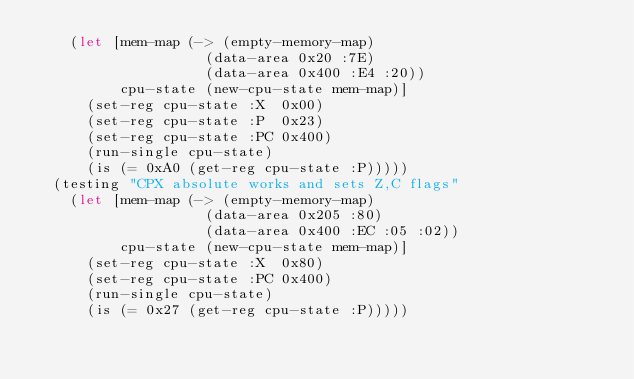<code> <loc_0><loc_0><loc_500><loc_500><_Clojure_>    (let [mem-map (-> (empty-memory-map)
                    (data-area 0x20 :7E)
                    (data-area 0x400 :E4 :20))
          cpu-state (new-cpu-state mem-map)]
      (set-reg cpu-state :X  0x00)
      (set-reg cpu-state :P  0x23)
      (set-reg cpu-state :PC 0x400)
      (run-single cpu-state)
      (is (= 0xA0 (get-reg cpu-state :P)))))
  (testing "CPX absolute works and sets Z,C flags"
    (let [mem-map (-> (empty-memory-map)
                    (data-area 0x205 :80)
                    (data-area 0x400 :EC :05 :02))
          cpu-state (new-cpu-state mem-map)]
      (set-reg cpu-state :X  0x80)
      (set-reg cpu-state :PC 0x400)
      (run-single cpu-state)
      (is (= 0x27 (get-reg cpu-state :P)))))</code> 